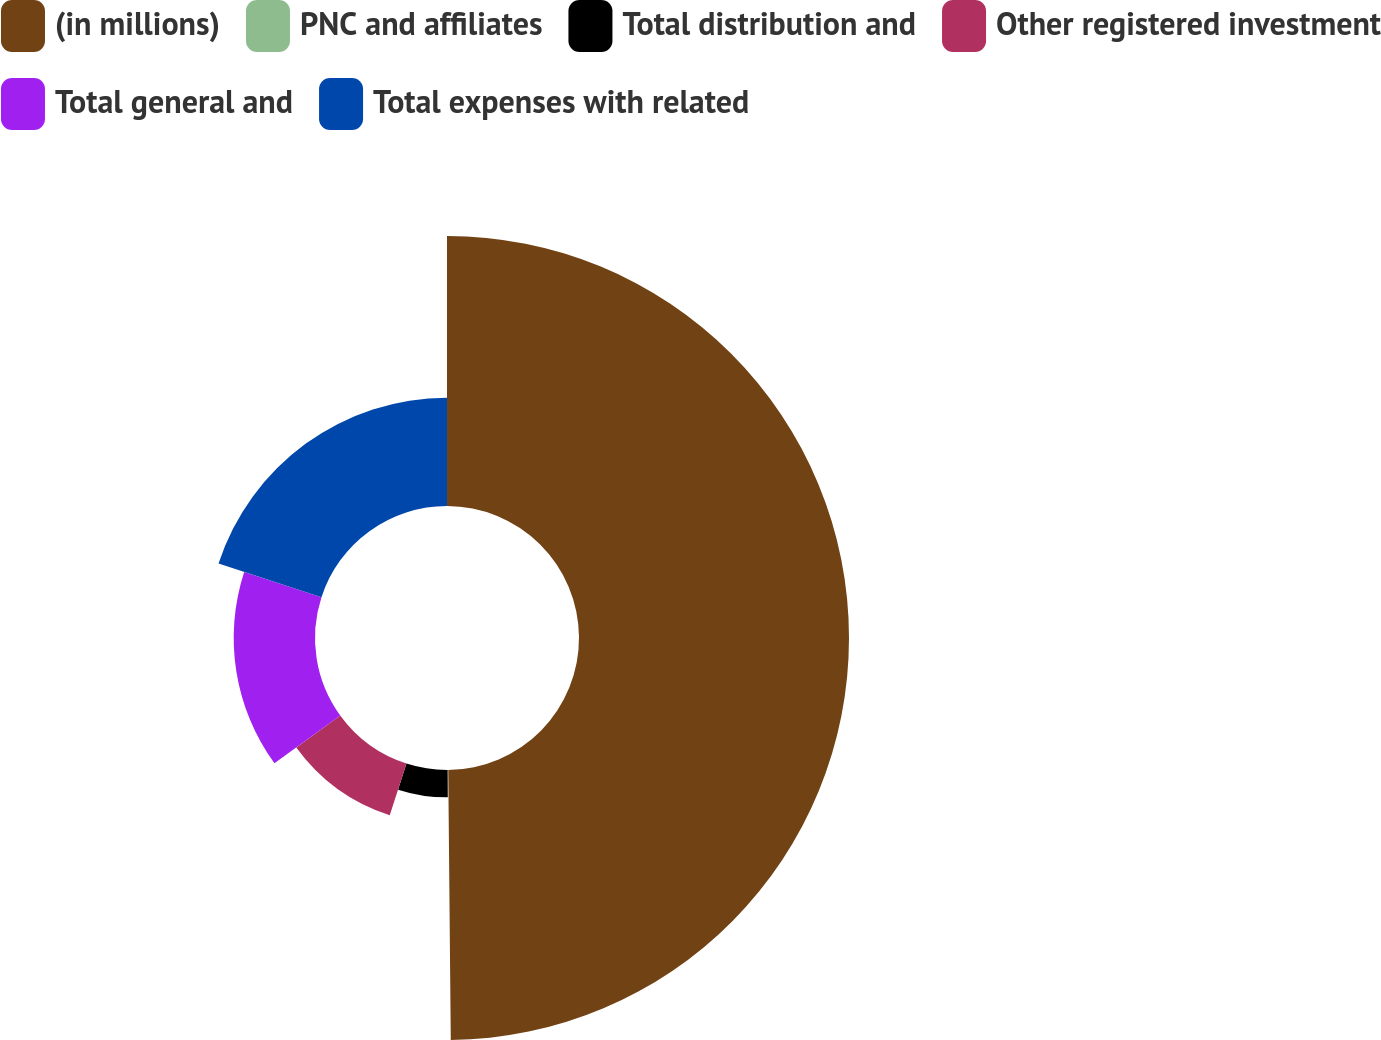Convert chart. <chart><loc_0><loc_0><loc_500><loc_500><pie_chart><fcel>(in millions)<fcel>PNC and affiliates<fcel>Total distribution and<fcel>Other registered investment<fcel>Total general and<fcel>Total expenses with related<nl><fcel>49.85%<fcel>0.07%<fcel>5.05%<fcel>10.03%<fcel>15.01%<fcel>19.99%<nl></chart> 